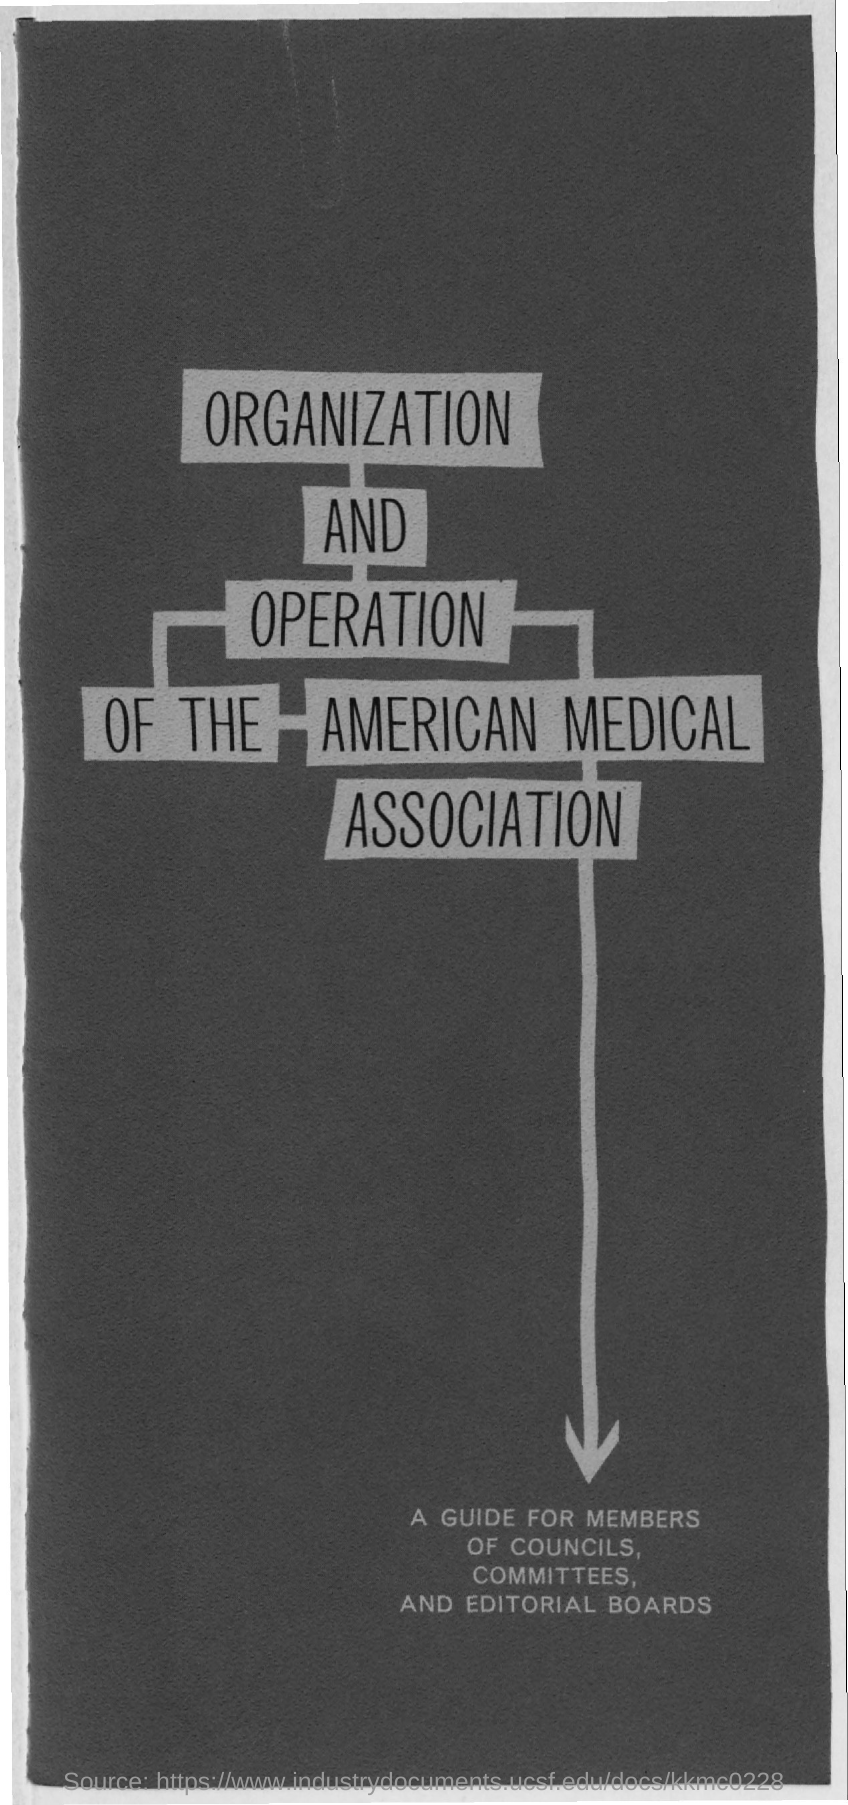Indicate a few pertinent items in this graphic. The title of the document is 'Organization and Operation of the American Medical Association.' 